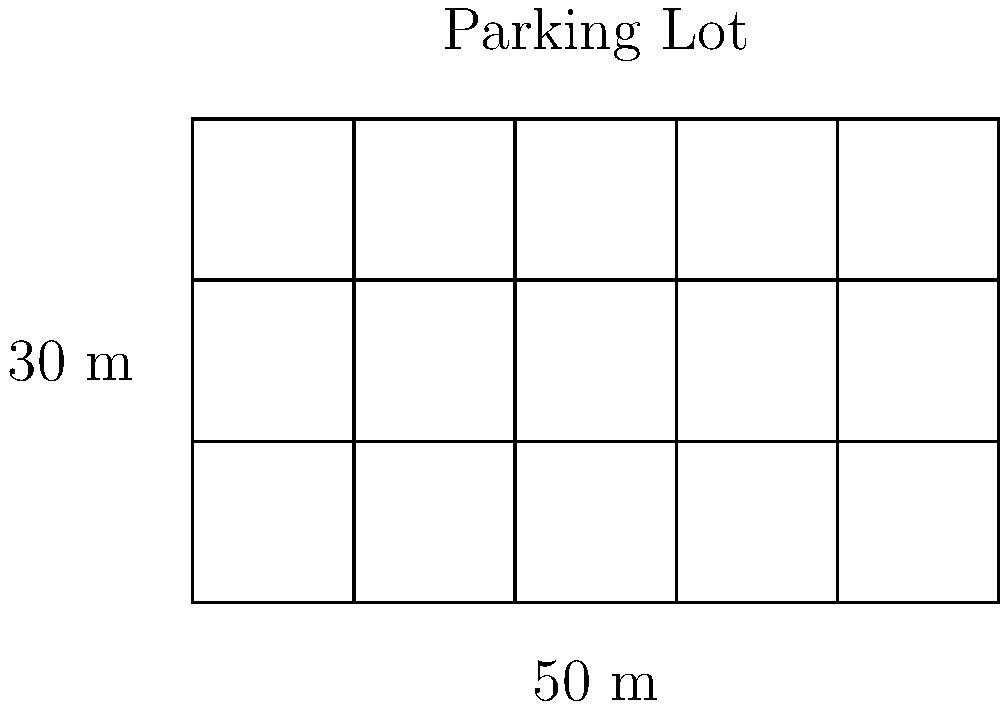As an admissions blogger, you're writing a post about campus facilities. You want to include information about parking availability. The campus has a rectangular parking lot that measures 50 meters by 30 meters, as shown in the diagram. Each parking space is 5 meters long and 3 meters wide. Calculate the total area of all the parking spaces in this lot. How many complete parking spaces can fit in this lot? Let's approach this step-by-step:

1) First, let's calculate the total area of the parking lot:
   Area = length × width
   $$ A = 50 \text{ m} \times 30 \text{ m} = 1500 \text{ m}^2 $$

2) Now, let's calculate the area of each parking space:
   $$ A_{space} = 5 \text{ m} \times 3 \text{ m} = 15 \text{ m}^2 $$

3) To find out how many complete parking spaces can fit, we need to divide the total area by the area of each space:
   $$ \text{Number of spaces} = \frac{1500 \text{ m}^2}{15 \text{ m}^2} = 100 $$

4) Therefore, 100 complete parking spaces can fit in this lot.

5) The total area of all parking spaces is:
   $$ A_{total} = 100 \times 15 \text{ m}^2 = 1500 \text{ m}^2 $$

This means that all of the lot's area is utilized for parking spaces in this ideal scenario.
Answer: 100 spaces; 1500 m² 